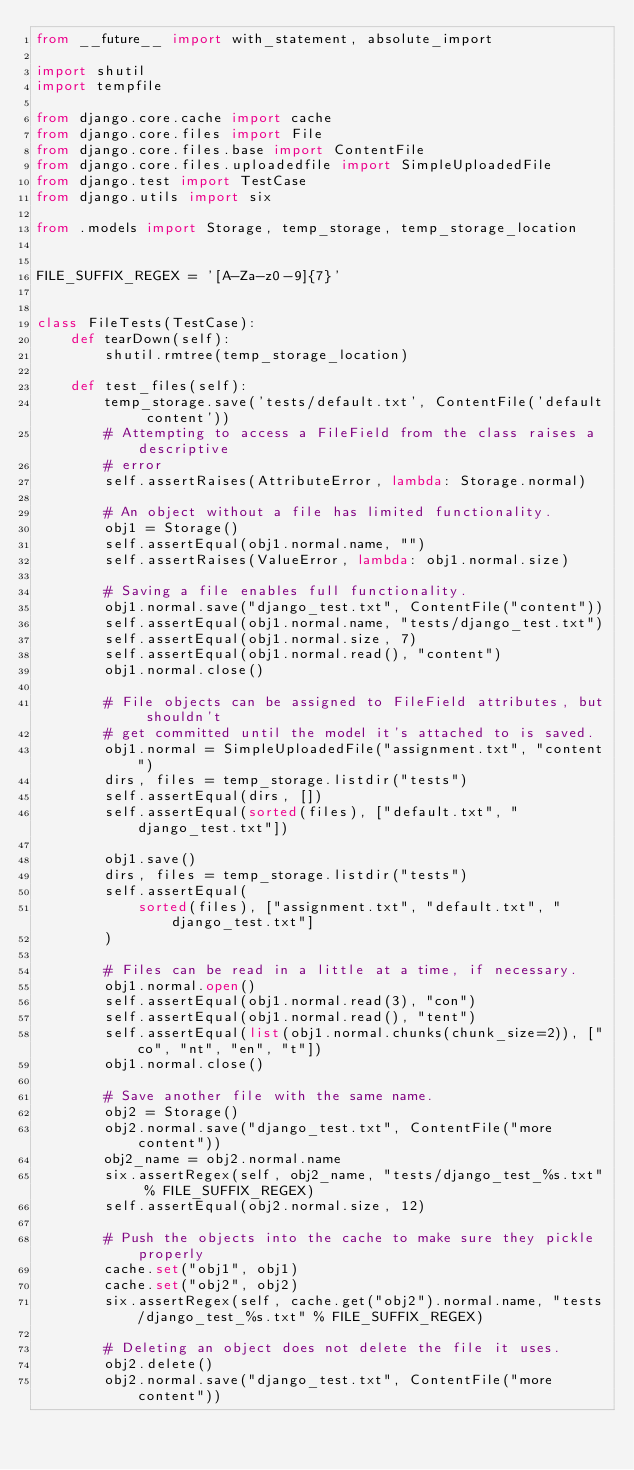Convert code to text. <code><loc_0><loc_0><loc_500><loc_500><_Python_>from __future__ import with_statement, absolute_import

import shutil
import tempfile

from django.core.cache import cache
from django.core.files import File
from django.core.files.base import ContentFile
from django.core.files.uploadedfile import SimpleUploadedFile
from django.test import TestCase
from django.utils import six

from .models import Storage, temp_storage, temp_storage_location


FILE_SUFFIX_REGEX = '[A-Za-z0-9]{7}'


class FileTests(TestCase):
    def tearDown(self):
        shutil.rmtree(temp_storage_location)

    def test_files(self):
        temp_storage.save('tests/default.txt', ContentFile('default content'))
        # Attempting to access a FileField from the class raises a descriptive
        # error
        self.assertRaises(AttributeError, lambda: Storage.normal)

        # An object without a file has limited functionality.
        obj1 = Storage()
        self.assertEqual(obj1.normal.name, "")
        self.assertRaises(ValueError, lambda: obj1.normal.size)

        # Saving a file enables full functionality.
        obj1.normal.save("django_test.txt", ContentFile("content"))
        self.assertEqual(obj1.normal.name, "tests/django_test.txt")
        self.assertEqual(obj1.normal.size, 7)
        self.assertEqual(obj1.normal.read(), "content")
        obj1.normal.close()

        # File objects can be assigned to FileField attributes, but shouldn't
        # get committed until the model it's attached to is saved.
        obj1.normal = SimpleUploadedFile("assignment.txt", "content")
        dirs, files = temp_storage.listdir("tests")
        self.assertEqual(dirs, [])
        self.assertEqual(sorted(files), ["default.txt", "django_test.txt"])

        obj1.save()
        dirs, files = temp_storage.listdir("tests")
        self.assertEqual(
            sorted(files), ["assignment.txt", "default.txt", "django_test.txt"]
        )

        # Files can be read in a little at a time, if necessary.
        obj1.normal.open()
        self.assertEqual(obj1.normal.read(3), "con")
        self.assertEqual(obj1.normal.read(), "tent")
        self.assertEqual(list(obj1.normal.chunks(chunk_size=2)), ["co", "nt", "en", "t"])
        obj1.normal.close()

        # Save another file with the same name.
        obj2 = Storage()
        obj2.normal.save("django_test.txt", ContentFile("more content"))
        obj2_name = obj2.normal.name
        six.assertRegex(self, obj2_name, "tests/django_test_%s.txt" % FILE_SUFFIX_REGEX)
        self.assertEqual(obj2.normal.size, 12)

        # Push the objects into the cache to make sure they pickle properly
        cache.set("obj1", obj1)
        cache.set("obj2", obj2)
        six.assertRegex(self, cache.get("obj2").normal.name, "tests/django_test_%s.txt" % FILE_SUFFIX_REGEX)

        # Deleting an object does not delete the file it uses.
        obj2.delete()
        obj2.normal.save("django_test.txt", ContentFile("more content"))</code> 